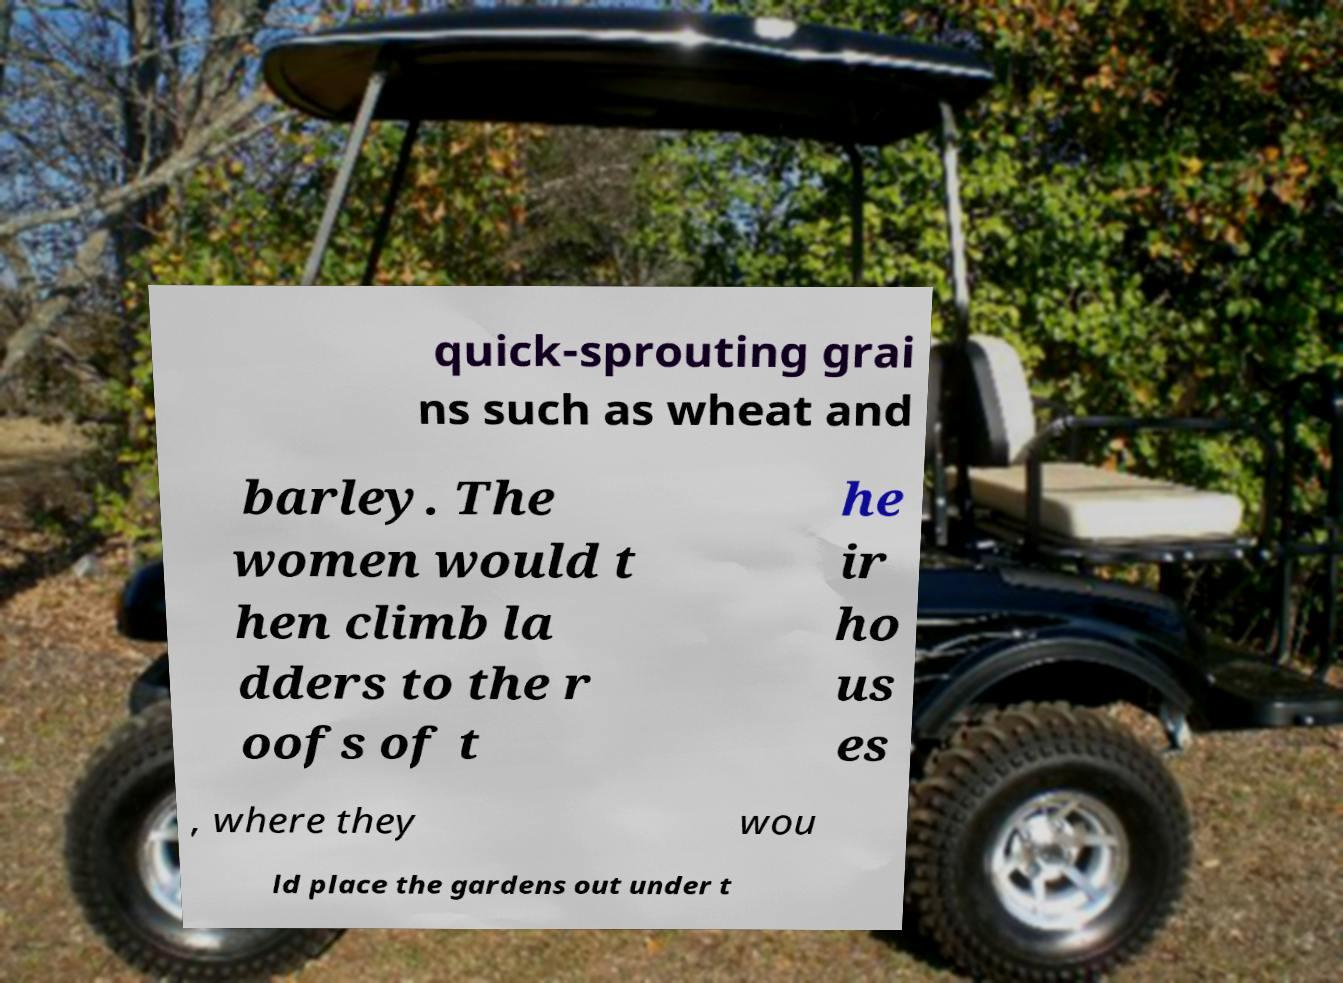I need the written content from this picture converted into text. Can you do that? quick-sprouting grai ns such as wheat and barley. The women would t hen climb la dders to the r oofs of t he ir ho us es , where they wou ld place the gardens out under t 